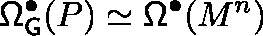<formula> <loc_0><loc_0><loc_500><loc_500>\Omega _ { G } ^ { \bullet } ( P ) \simeq \Omega ^ { \bullet } ( M ^ { n } )</formula> 